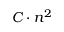Convert formula to latex. <formula><loc_0><loc_0><loc_500><loc_500>C \cdot n ^ { 2 }</formula> 